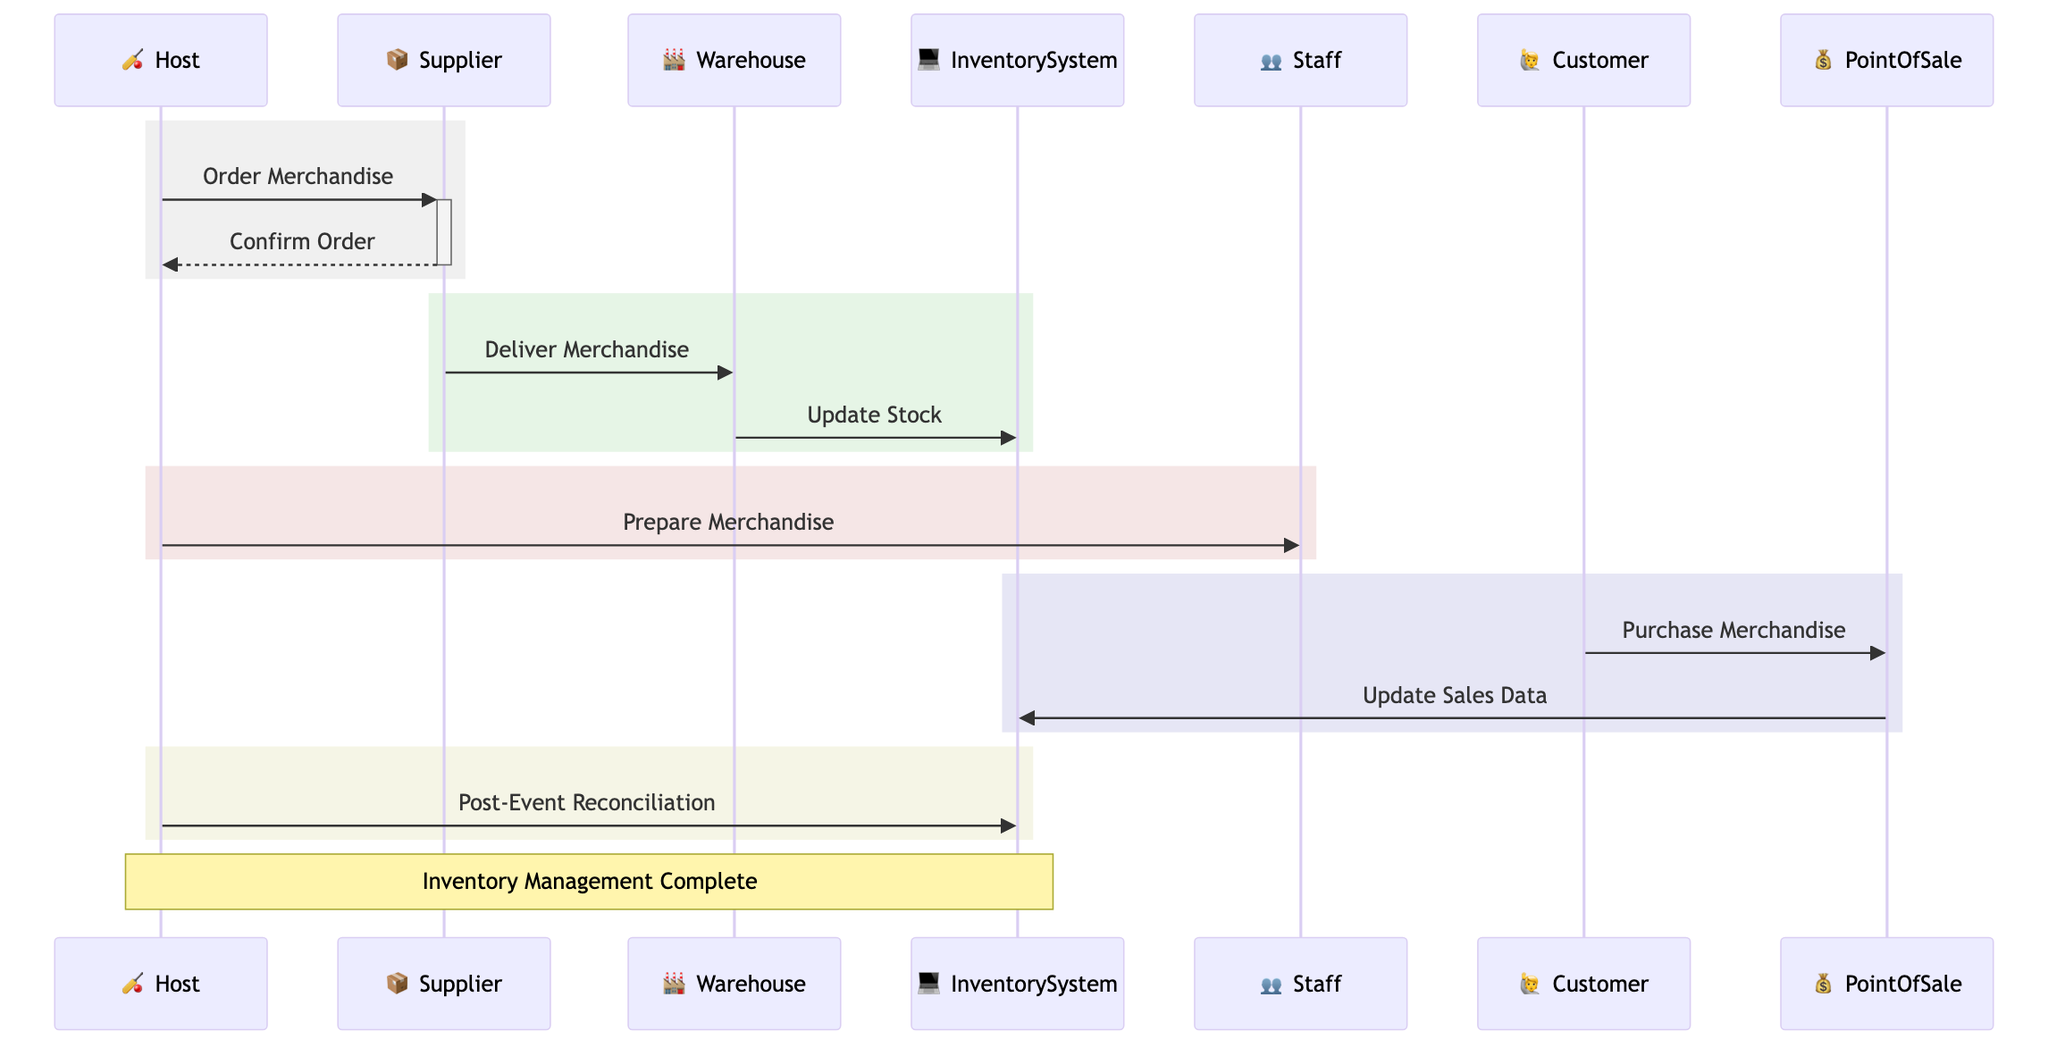What's the first message in the sequence? The first message is sent from the Host to the Supplier, with the content "Order Merchandise." This is the initial action that triggers the inventory management process for the cricket event merchandise.
Answer: Order Merchandise How many participants are there in the diagram? The diagram features a total of seven participants, which include the Host, Supplier, Warehouse, Inventory System, Staff, Customer, and Point of Sale. By counting these entities, we ascertain the number of active roles in the inventory management process.
Answer: 7 Who confirms the order after the merchandise is ordered? The Supplier confirms the order after the Host places the order for the merchandise. This is a direct response from the Supplier indicating acknowledgment of the order placed by the Host.
Answer: Supplier What action does the Warehouse perform after receiving merchandise? After the merchandise is delivered, the Warehouse is responsible for updating the Inventory System with the new stock, ensuring that the inventory reflects the new merchandise available for the event.
Answer: Update Stock During the event, what action do Customers take related to the merchandise? Customers purchase merchandise during the event. This action indicates the sale of inventory and connects directly with the Point of Sale system for processing transactions.
Answer: Purchase Merchandise What is the last action the Host takes after the event? The last action taken by the Host is to perform Post-Event Reconciliation to match sales data with remaining stock. This ensures accurate inventory management by reconciling the amounts sold against what was available.
Answer: Post-Event Reconciliation How does the Point of Sale system relate to the Inventory System during the event? The Point of Sale system updates the Inventory System with sales data in real-time after Customers purchase merchandise. This keeps the inventory records current and accurate throughout the event.
Answer: Update Sales Data What is the role of the Staff in the inventory management process? The Staff prepares and displays the merchandise for the event as instructed by the Host. This ensures that the merchandise is ready for sale and professionally presented to Customers.
Answer: Prepare Merchandise 